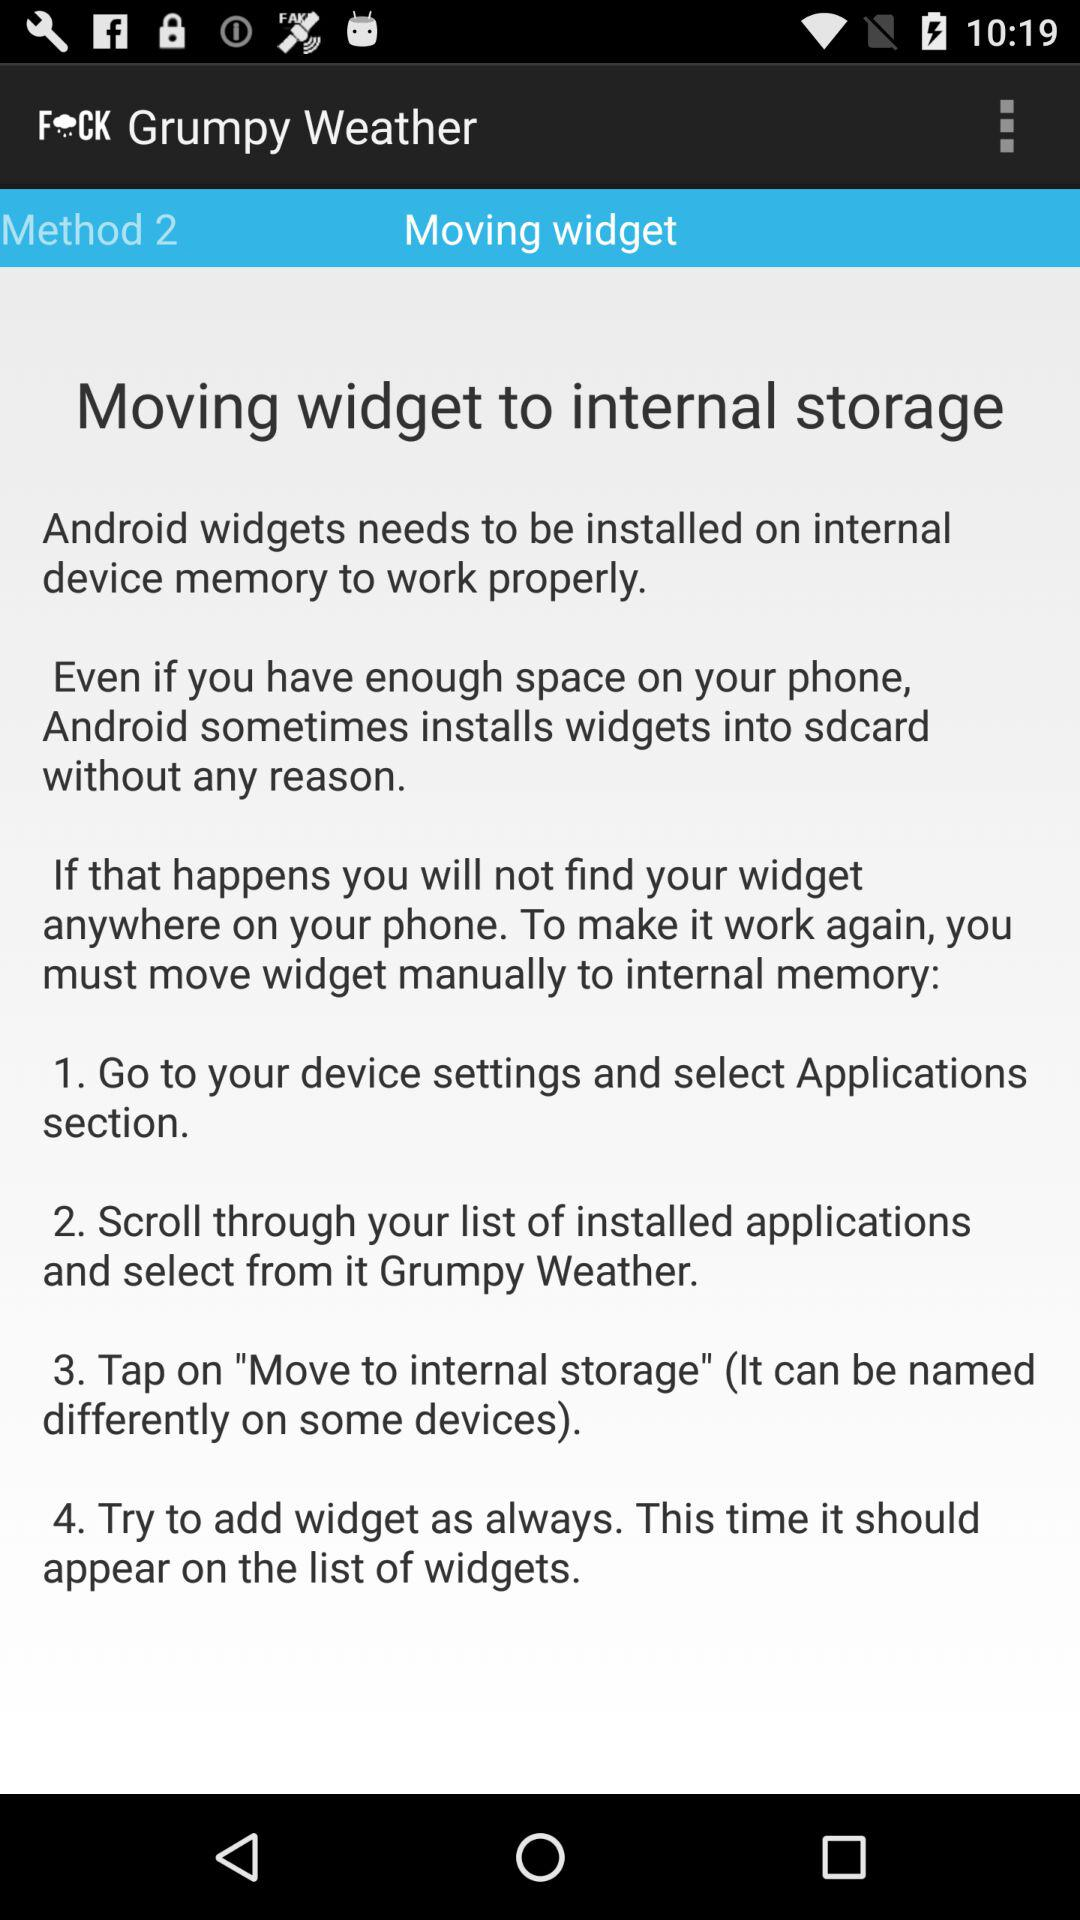How many steps are there to fix the widget?
Answer the question using a single word or phrase. 4 